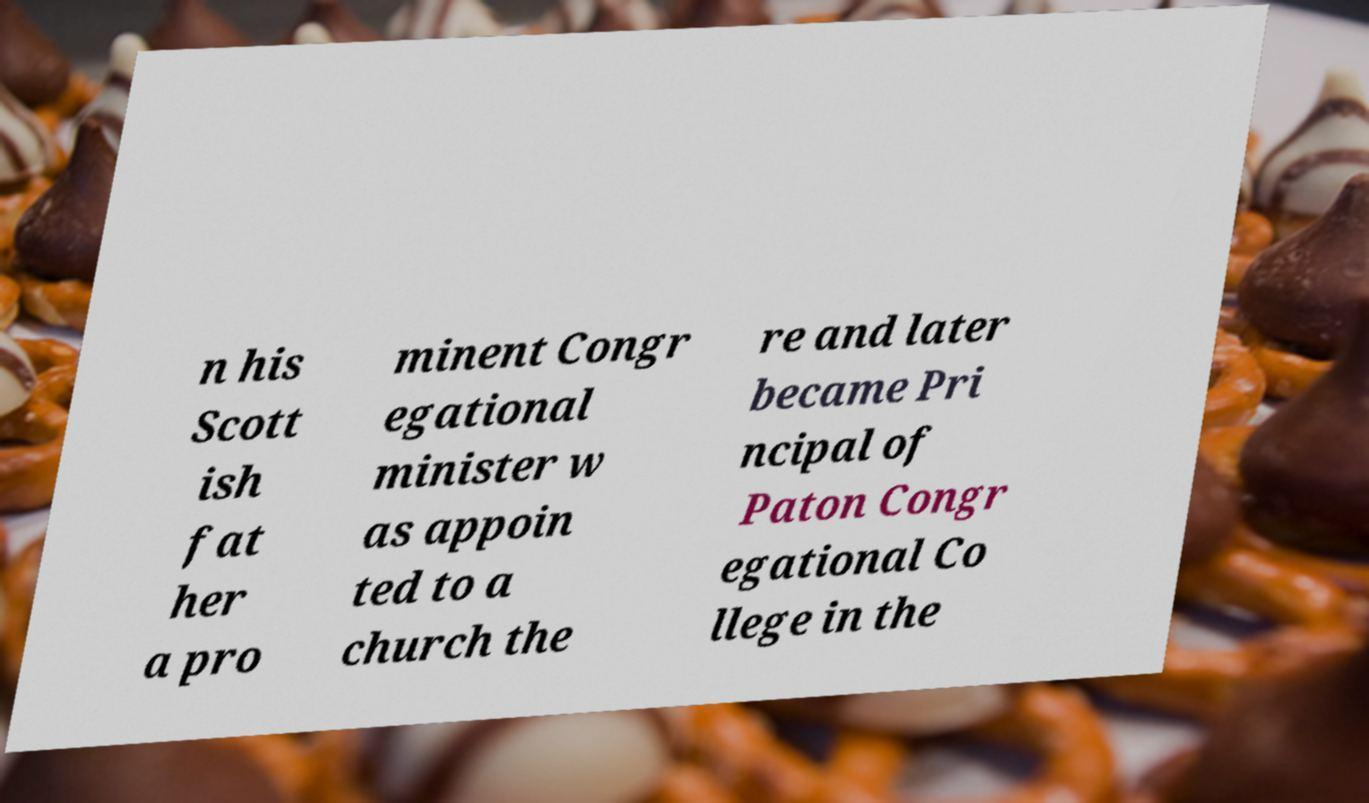Please identify and transcribe the text found in this image. n his Scott ish fat her a pro minent Congr egational minister w as appoin ted to a church the re and later became Pri ncipal of Paton Congr egational Co llege in the 